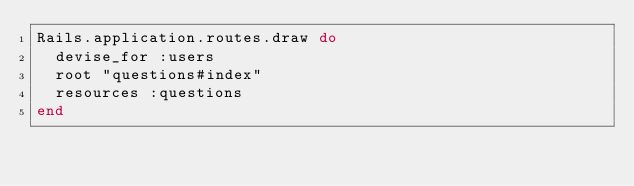<code> <loc_0><loc_0><loc_500><loc_500><_Ruby_>Rails.application.routes.draw do
  devise_for :users
  root "questions#index"
  resources :questions
end
</code> 